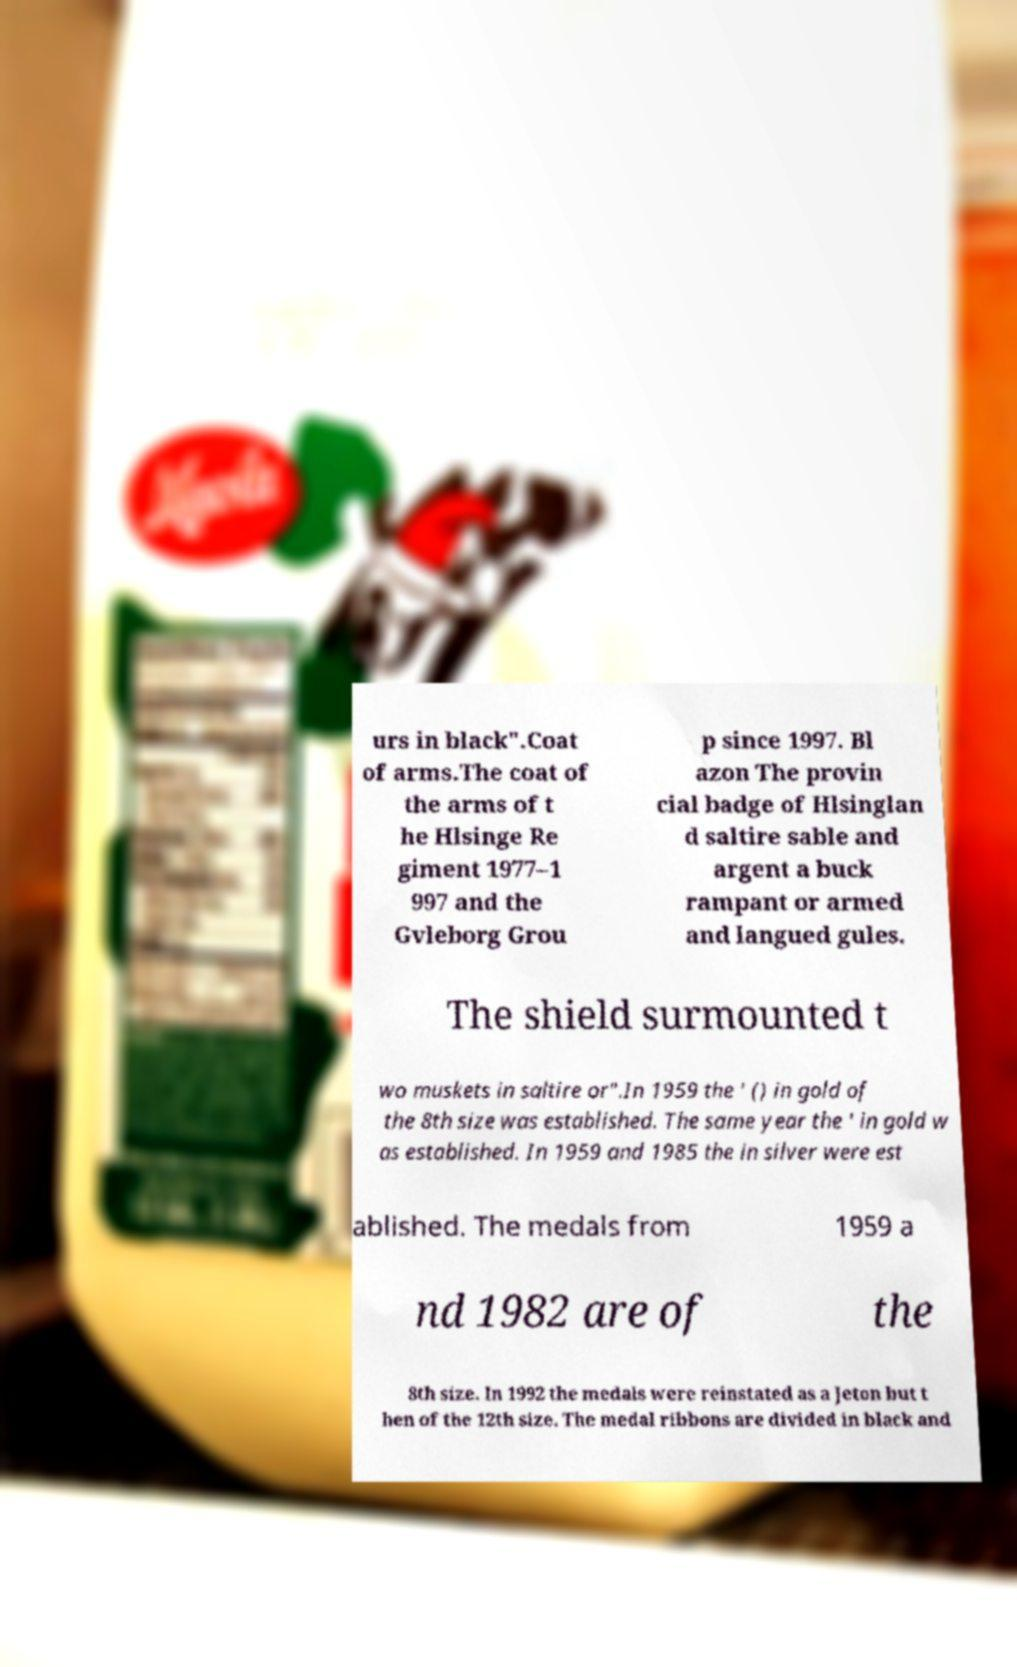I need the written content from this picture converted into text. Can you do that? urs in black".Coat of arms.The coat of the arms of t he Hlsinge Re giment 1977–1 997 and the Gvleborg Grou p since 1997. Bl azon The provin cial badge of Hlsinglan d saltire sable and argent a buck rampant or armed and langued gules. The shield surmounted t wo muskets in saltire or".In 1959 the ' () in gold of the 8th size was established. The same year the ' in gold w as established. In 1959 and 1985 the in silver were est ablished. The medals from 1959 a nd 1982 are of the 8th size. In 1992 the medals were reinstated as a Jeton but t hen of the 12th size. The medal ribbons are divided in black and 